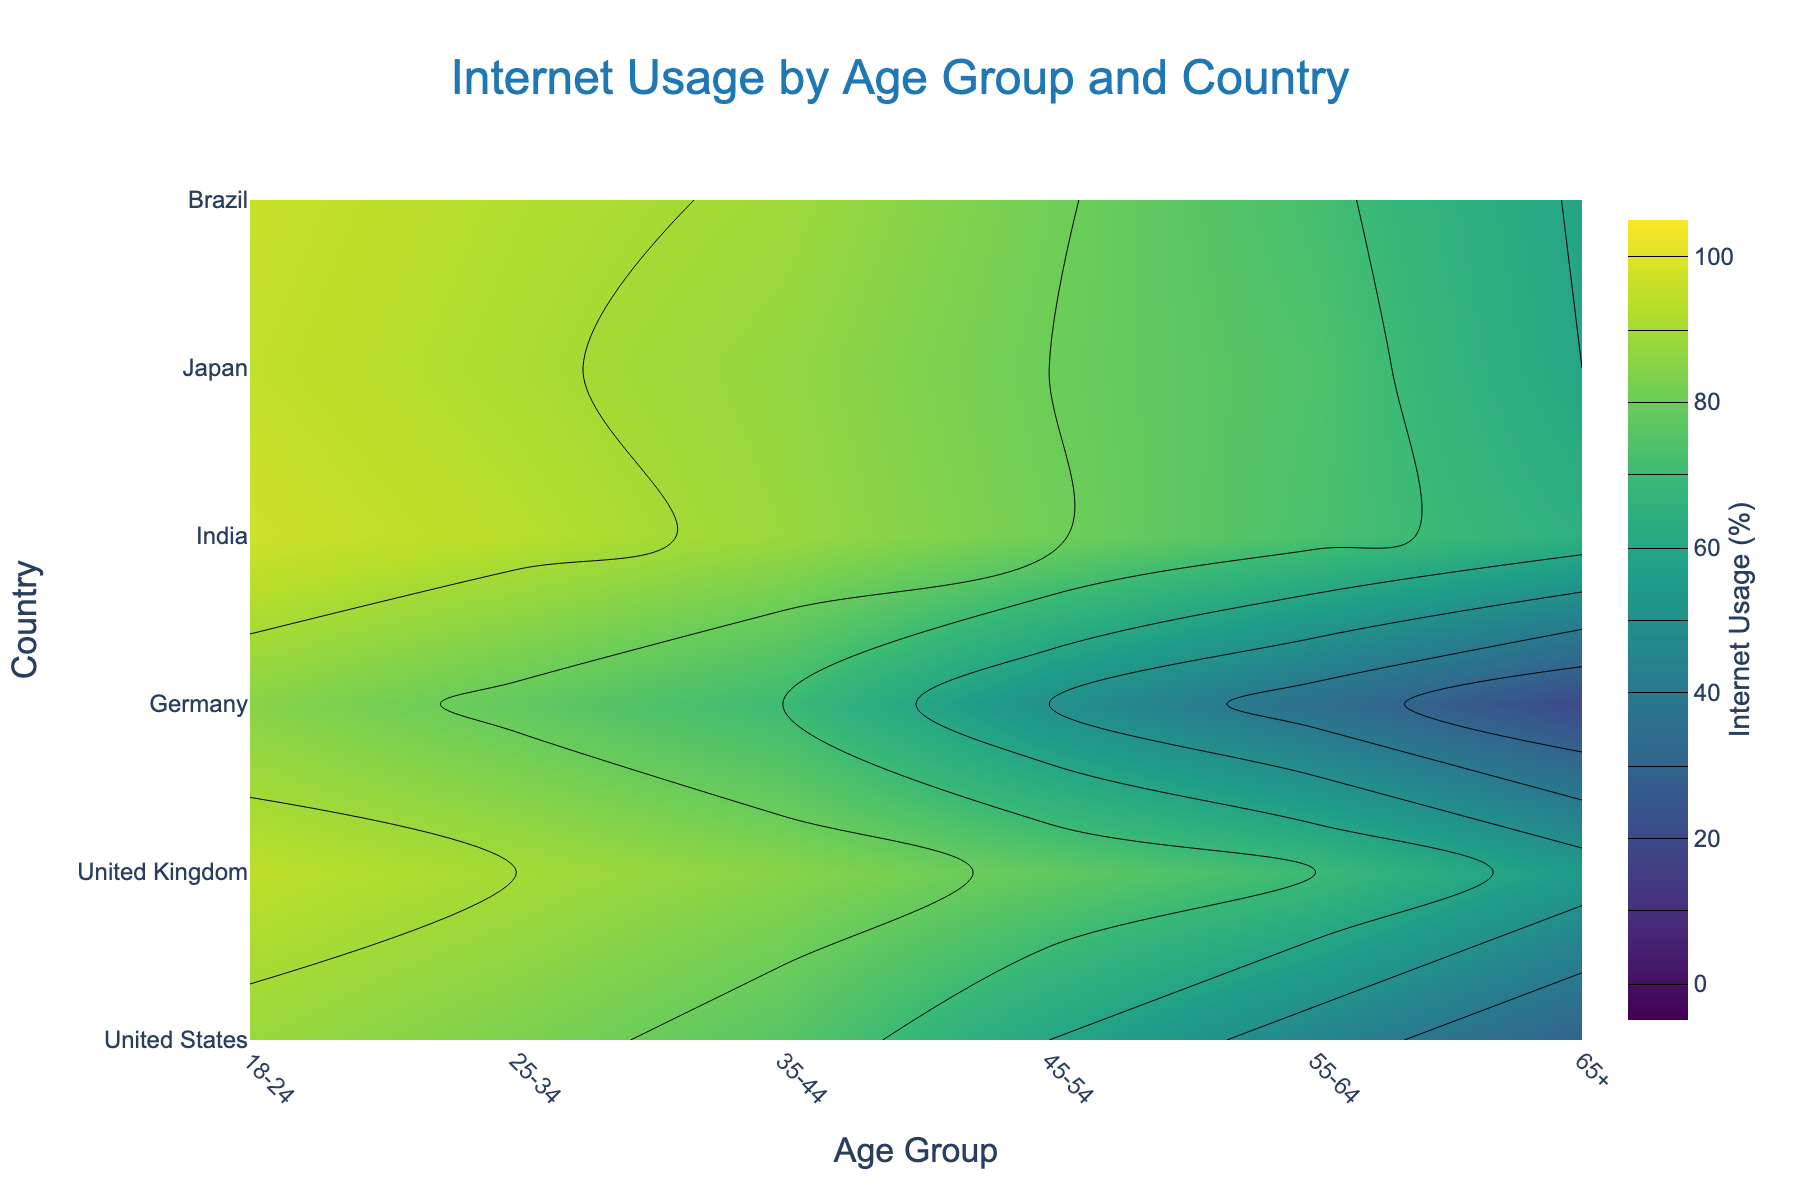What is the title of the contour plot? The title is located at the top center of the plot, indicating the purpose of the visualization.
Answer: Internet Usage by Age Group and Country What age group has the highest internet usage in Japan? Check the contour plot for the highest value within the row for Japan across the age groups.
Answer: 18-24 Which country has the lowest internet usage among the 65+ age group? Look at the values along the 65+ age group's column and identify the smallest value. India's value is the smallest.
Answer: India Compare the internet usage percentages between the 18-24 age group in the United States and Brazil. Which country has higher usage? Locate the values for the 18-24 age group for both countries and compare them. The United States has 96%, and Brazil has 88%.
Answer: United States What is the average internet usage percentage for the age groups in Germany? Add the internet usage percentages for all the age groups in Germany and divide by the number of age groups (6). (94 + 90 + 85 + 78 + 70 + 55) / 6 = 78.67
Answer: 78.67 Determine the difference in internet usage percentage between the youngest (18-24) and oldest (65+) age groups in the United Kingdom. Identify the internet usage for the 18-24 age group (95%) and the 65+ age group (60%) in the United Kingdom and compute the difference, which is 95 - 60.
Answer: 35 Which country has the steepest decline in internet usage when moving from the 35-44 age group to the 45-54 age group? Calculate the difference between 35-44 and 45-54 age groups for each country, and identify the largest decline. India has the largest difference (70 - 50 = 20%).
Answer: India Is there a country with consistent internet usage above 70% across all age groups? Verify that all age groups for a country have values above 70%. The United States and Japan meet this criterion.
Answer: Yes How does the internet usage trend in Brazil differ from that in the United States as age increases? Observe the contour lines for both countries. Brazil shows a steep decline starting from younger age groups, whereas the USA shows a gradual decline.
Answer: Brazil declines more steeply What is the median internet usage percentage for the 55-64 age group across all countries? List the internet usage percentages for the 55-64 age group (72, 74, 70, 35, 73, 45), sort them (35, 45, 70, 72, 73, 74), and find the median value [(70+72)/2].
Answer: 71 